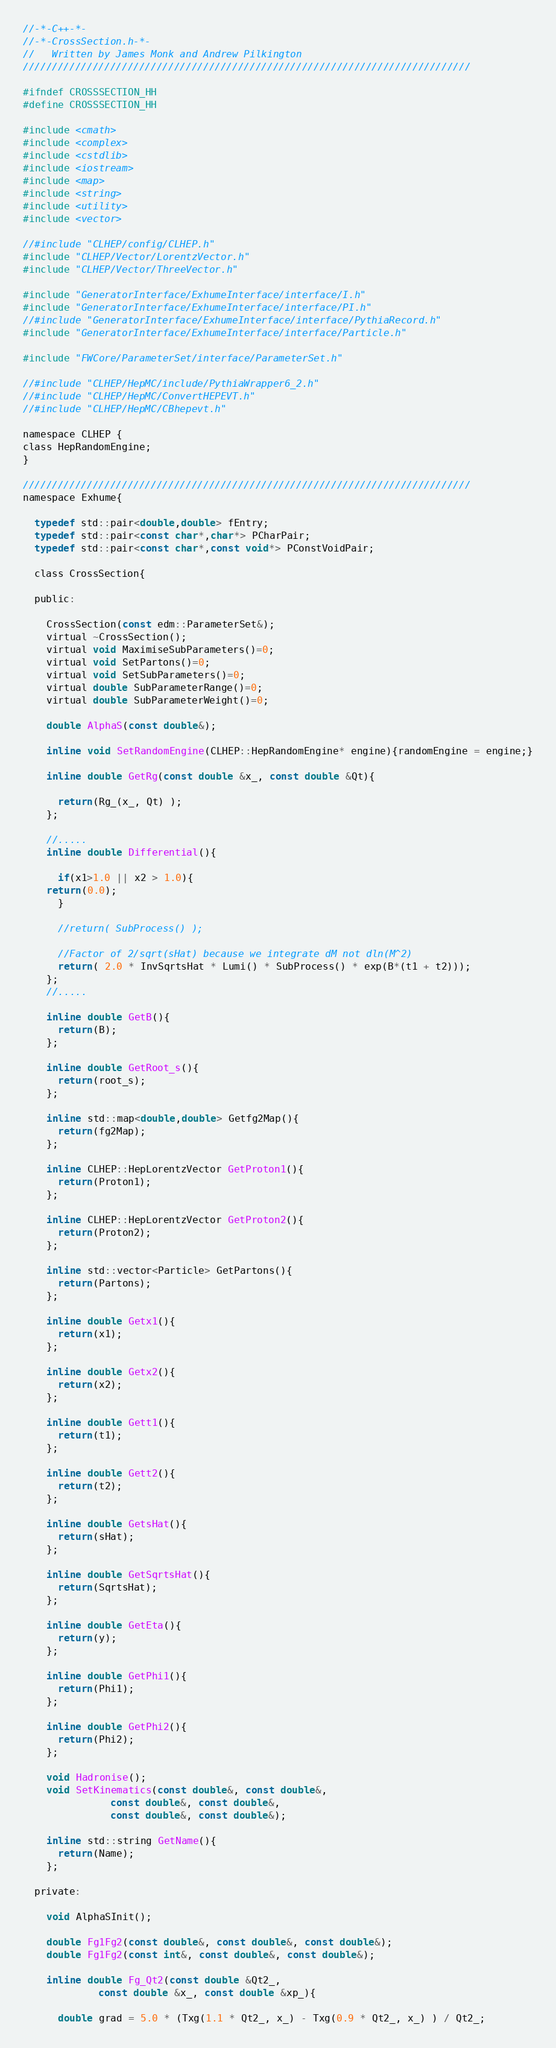<code> <loc_0><loc_0><loc_500><loc_500><_C_>//-*-C++-*-
//-*-CrossSection.h-*-
//   Written by James Monk and Andrew Pilkington
/////////////////////////////////////////////////////////////////////////////

#ifndef CROSSSECTION_HH
#define CROSSSECTION_HH

#include <cmath>
#include <complex>
#include <cstdlib>
#include <iostream>
#include <map>
#include <string>
#include <utility>
#include <vector>

//#include "CLHEP/config/CLHEP.h"
#include "CLHEP/Vector/LorentzVector.h"
#include "CLHEP/Vector/ThreeVector.h"

#include "GeneratorInterface/ExhumeInterface/interface/I.h"
#include "GeneratorInterface/ExhumeInterface/interface/PI.h"
//#include "GeneratorInterface/ExhumeInterface/interface/PythiaRecord.h"
#include "GeneratorInterface/ExhumeInterface/interface/Particle.h"

#include "FWCore/ParameterSet/interface/ParameterSet.h"

//#include "CLHEP/HepMC/include/PythiaWrapper6_2.h"
//#include "CLHEP/HepMC/ConvertHEPEVT.h"
//#include "CLHEP/HepMC/CBhepevt.h"

namespace CLHEP {
class HepRandomEngine;
}

/////////////////////////////////////////////////////////////////////////////
namespace Exhume{
  
  typedef std::pair<double,double> fEntry;
  typedef std::pair<const char*,char*> PCharPair;
  typedef std::pair<const char*,const void*> PConstVoidPair;
  
  class CrossSection{

  public:

    CrossSection(const edm::ParameterSet&);
    virtual ~CrossSection();
    virtual void MaximiseSubParameters()=0;
    virtual void SetPartons()=0;
    virtual void SetSubParameters()=0;
    virtual double SubParameterRange()=0;
    virtual double SubParameterWeight()=0;

    double AlphaS(const double&);

    inline void SetRandomEngine(CLHEP::HepRandomEngine* engine){randomEngine = engine;}

    inline double GetRg(const double &x_, const double &Qt){

      return(Rg_(x_, Qt) );
    };

    //.....
    inline double Differential(){

      if(x1>1.0 || x2 > 1.0){
	return(0.0);
      }

      //return( SubProcess() );

      //Factor of 2/sqrt(sHat) because we integrate dM not dln(M^2)
      return( 2.0 * InvSqrtsHat * Lumi() * SubProcess() * exp(B*(t1 + t2))); 
    };
    //.....

    inline double GetB(){
      return(B);
    };

    inline double GetRoot_s(){
      return(root_s);
    };

    inline std::map<double,double> Getfg2Map(){
      return(fg2Map);
    };

    inline CLHEP::HepLorentzVector GetProton1(){
      return(Proton1);
    };

    inline CLHEP::HepLorentzVector GetProton2(){
      return(Proton2);
    };

    inline std::vector<Particle> GetPartons(){
      return(Partons);
    };

    inline double Getx1(){
      return(x1);
    };
    
    inline double Getx2(){
      return(x2);
    };

    inline double Gett1(){
      return(t1);
    };

    inline double Gett2(){
      return(t2);
    };
    
    inline double GetsHat(){
      return(sHat);
    };

    inline double GetSqrtsHat(){
      return(SqrtsHat);
    };

    inline double GetEta(){
      return(y);
    };

    inline double GetPhi1(){
      return(Phi1);
    };

    inline double GetPhi2(){
      return(Phi2);
    };

    void Hadronise();
    void SetKinematics(const double&, const double&,
		       const double&, const double&, 
		       const double&, const double&);

    inline std::string GetName(){
      return(Name);
    };

  private:

    void AlphaSInit();

    double Fg1Fg2(const double&, const double&, const double&);
    double Fg1Fg2(const int&, const double&, const double&);

    inline double Fg_Qt2(const double &Qt2_, 
			 const double &x_, const double &xp_){

      double grad = 5.0 * (Txg(1.1 * Qt2_, x_) - Txg(0.9 * Qt2_, x_) ) / Qt2_;
</code> 